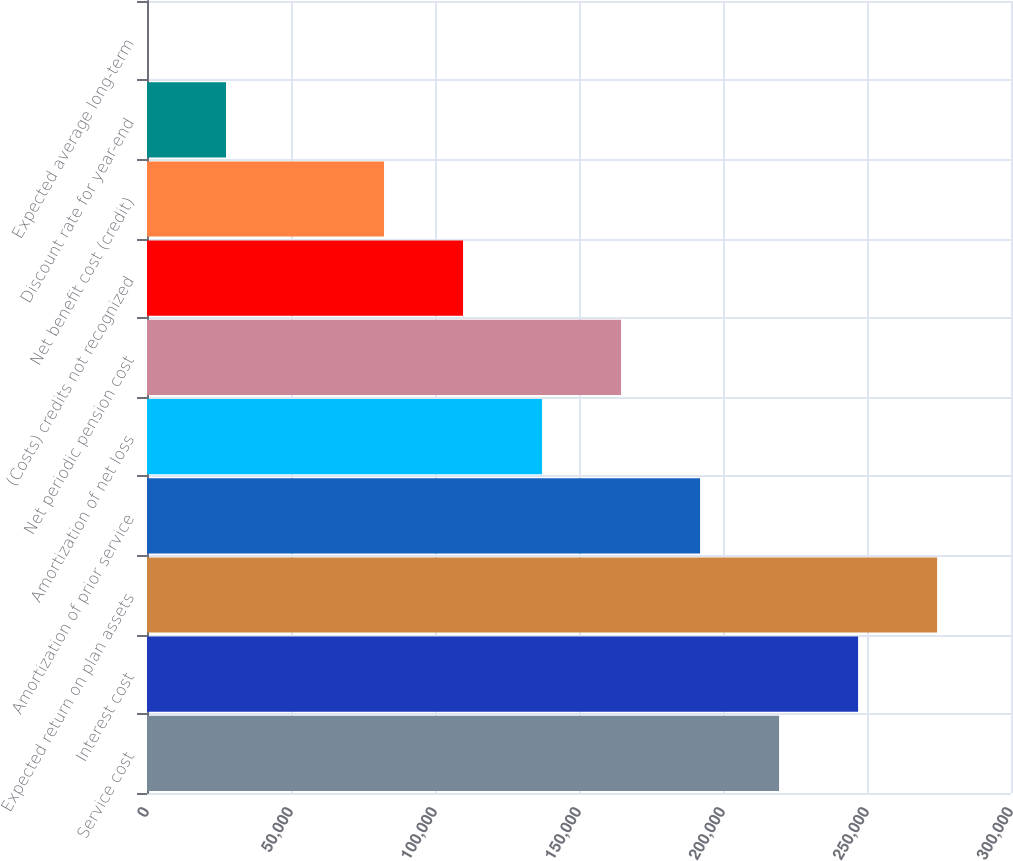Convert chart. <chart><loc_0><loc_0><loc_500><loc_500><bar_chart><fcel>Service cost<fcel>Interest cost<fcel>Expected return on plan assets<fcel>Amortization of prior service<fcel>Amortization of net loss<fcel>Net periodic pension cost<fcel>(Costs) credits not recognized<fcel>Net benefit cost (credit)<fcel>Discount rate for year-end<fcel>Expected average long-term<nl><fcel>219471<fcel>246905<fcel>274338<fcel>192038<fcel>137171<fcel>164604<fcel>109738<fcel>82304.2<fcel>27437.4<fcel>4<nl></chart> 